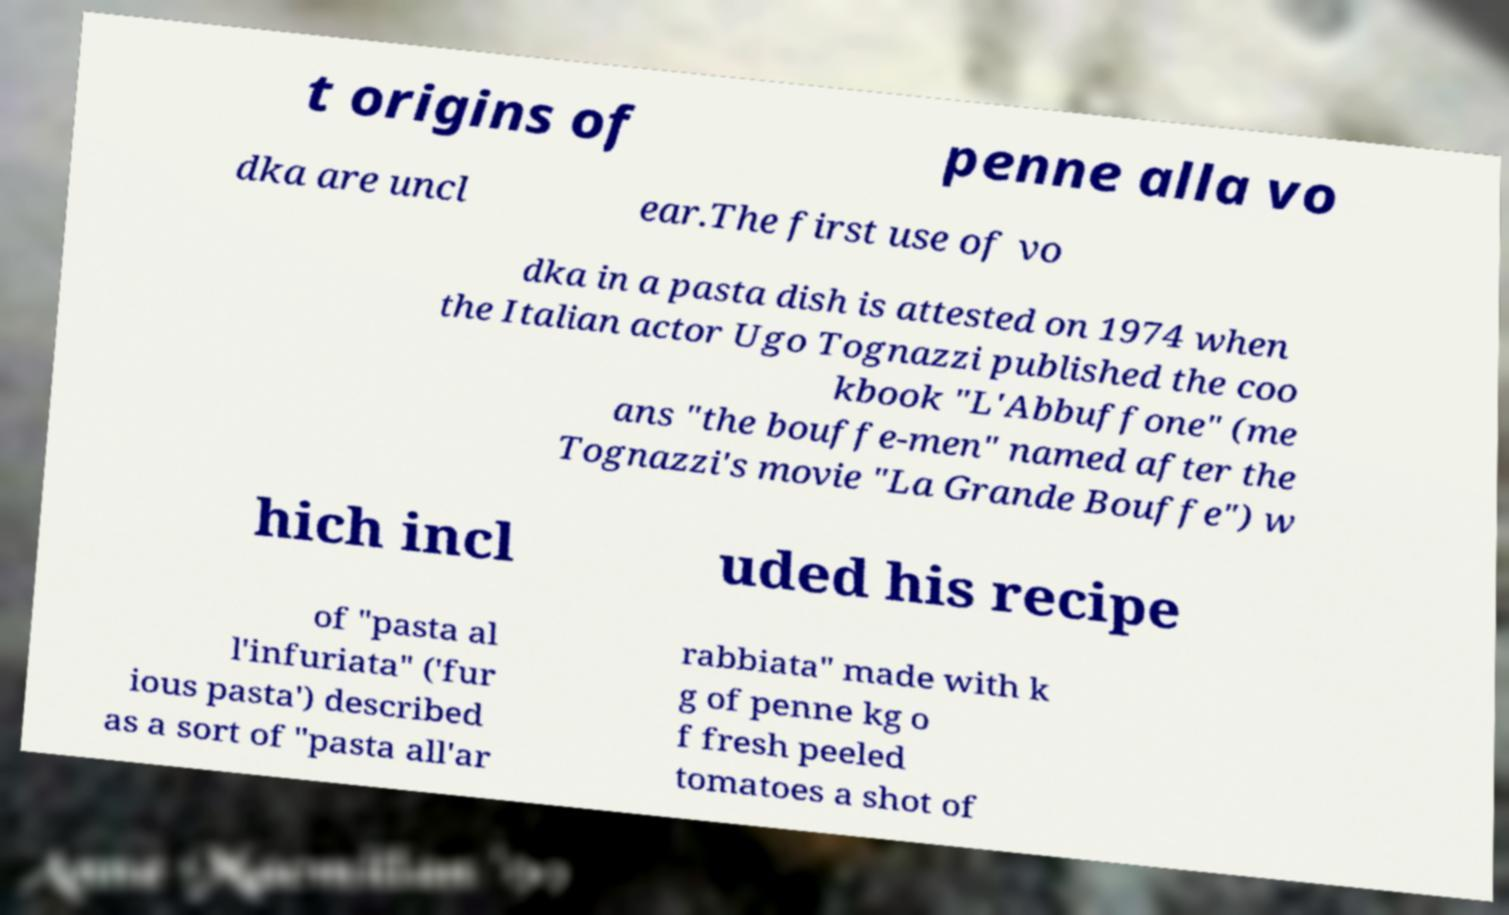Please identify and transcribe the text found in this image. t origins of penne alla vo dka are uncl ear.The first use of vo dka in a pasta dish is attested on 1974 when the Italian actor Ugo Tognazzi published the coo kbook "L'Abbuffone" (me ans "the bouffe-men" named after the Tognazzi's movie "La Grande Bouffe") w hich incl uded his recipe of "pasta al l'infuriata" ('fur ious pasta') described as a sort of "pasta all'ar rabbiata" made with k g of penne kg o f fresh peeled tomatoes a shot of 